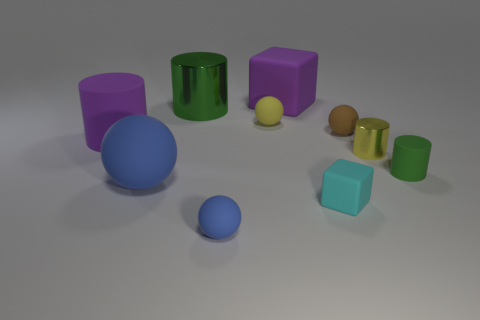How many other objects are the same shape as the brown rubber thing?
Your answer should be very brief. 3. What is the shape of the large blue matte thing in front of the purple rubber thing that is behind the green thing that is behind the big purple matte cylinder?
Offer a terse response. Sphere. What number of things are either tiny cyan balls or metallic objects that are to the right of the purple matte cube?
Offer a terse response. 1. Does the yellow rubber object behind the cyan rubber cube have the same shape as the green thing that is right of the small yellow matte sphere?
Ensure brevity in your answer.  No. What number of things are small yellow metallic objects or blue blocks?
Your answer should be very brief. 1. Is there any other thing that is the same material as the big green object?
Offer a very short reply. Yes. Are any big gray objects visible?
Your response must be concise. No. Does the blue ball behind the small blue object have the same material as the tiny cyan cube?
Offer a terse response. Yes. Is there a large green object that has the same shape as the tiny yellow metallic thing?
Your answer should be compact. Yes. Is the number of tiny brown spheres behind the big matte cube the same as the number of rubber blocks?
Your answer should be very brief. No. 